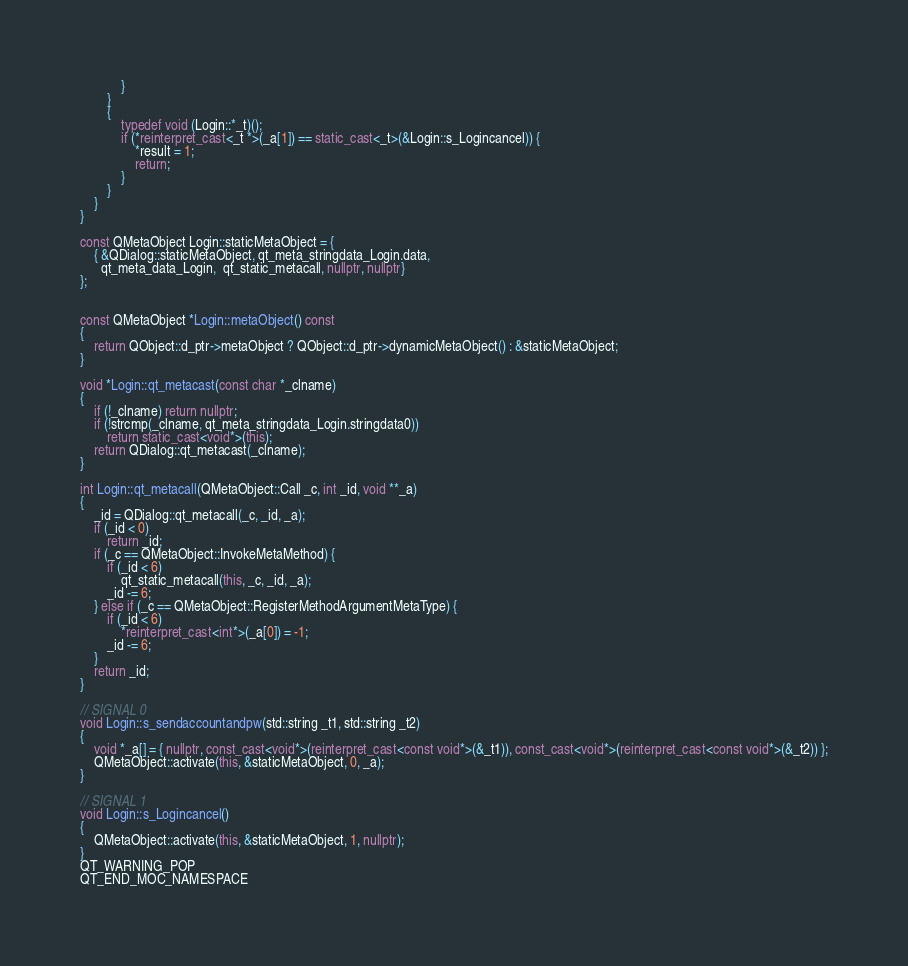Convert code to text. <code><loc_0><loc_0><loc_500><loc_500><_C++_>            }
        }
        {
            typedef void (Login::*_t)();
            if (*reinterpret_cast<_t *>(_a[1]) == static_cast<_t>(&Login::s_Logincancel)) {
                *result = 1;
                return;
            }
        }
    }
}

const QMetaObject Login::staticMetaObject = {
    { &QDialog::staticMetaObject, qt_meta_stringdata_Login.data,
      qt_meta_data_Login,  qt_static_metacall, nullptr, nullptr}
};


const QMetaObject *Login::metaObject() const
{
    return QObject::d_ptr->metaObject ? QObject::d_ptr->dynamicMetaObject() : &staticMetaObject;
}

void *Login::qt_metacast(const char *_clname)
{
    if (!_clname) return nullptr;
    if (!strcmp(_clname, qt_meta_stringdata_Login.stringdata0))
        return static_cast<void*>(this);
    return QDialog::qt_metacast(_clname);
}

int Login::qt_metacall(QMetaObject::Call _c, int _id, void **_a)
{
    _id = QDialog::qt_metacall(_c, _id, _a);
    if (_id < 0)
        return _id;
    if (_c == QMetaObject::InvokeMetaMethod) {
        if (_id < 6)
            qt_static_metacall(this, _c, _id, _a);
        _id -= 6;
    } else if (_c == QMetaObject::RegisterMethodArgumentMetaType) {
        if (_id < 6)
            *reinterpret_cast<int*>(_a[0]) = -1;
        _id -= 6;
    }
    return _id;
}

// SIGNAL 0
void Login::s_sendaccountandpw(std::string _t1, std::string _t2)
{
    void *_a[] = { nullptr, const_cast<void*>(reinterpret_cast<const void*>(&_t1)), const_cast<void*>(reinterpret_cast<const void*>(&_t2)) };
    QMetaObject::activate(this, &staticMetaObject, 0, _a);
}

// SIGNAL 1
void Login::s_Logincancel()
{
    QMetaObject::activate(this, &staticMetaObject, 1, nullptr);
}
QT_WARNING_POP
QT_END_MOC_NAMESPACE
</code> 